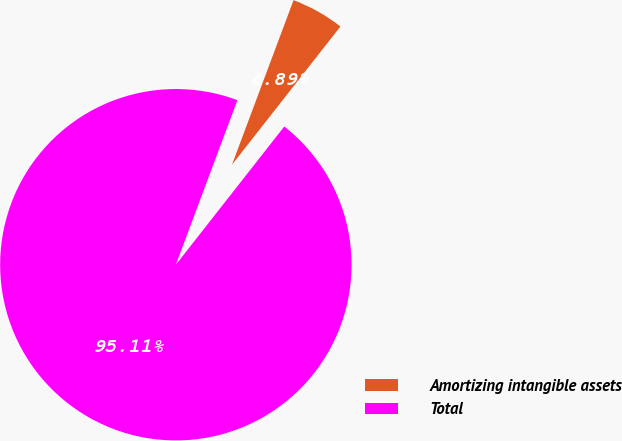<chart> <loc_0><loc_0><loc_500><loc_500><pie_chart><fcel>Amortizing intangible assets<fcel>Total<nl><fcel>4.89%<fcel>95.11%<nl></chart> 